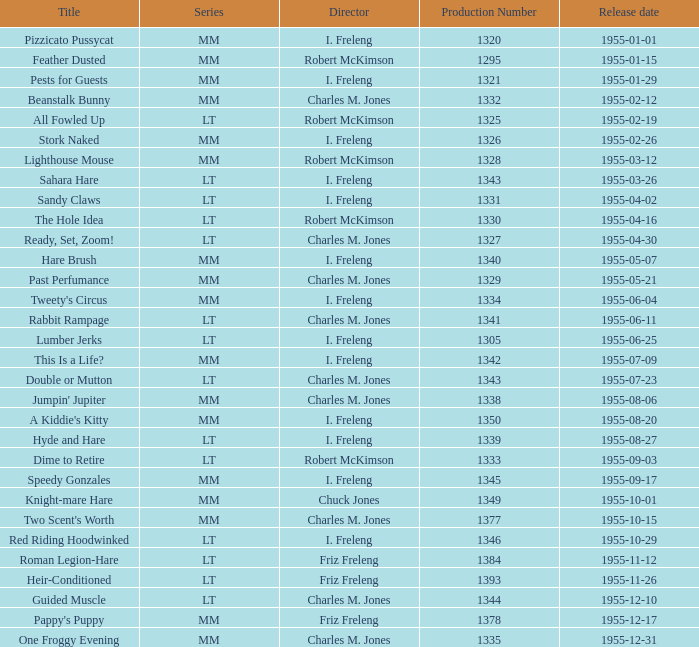What is the highest production number released on 1955-04-02 with i. freleng as the director? 1331.0. 